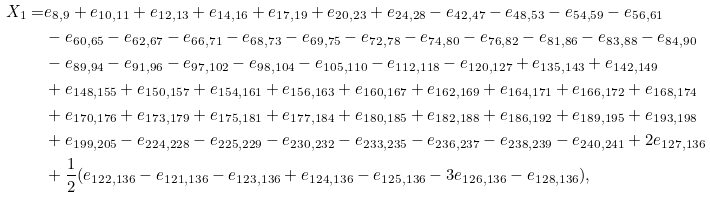Convert formula to latex. <formula><loc_0><loc_0><loc_500><loc_500>X _ { 1 } = & e _ { 8 , 9 } + e _ { 1 0 , 1 1 } + e _ { 1 2 , 1 3 } + e _ { 1 4 , 1 6 } + e _ { 1 7 , 1 9 } + e _ { 2 0 , 2 3 } + e _ { 2 4 , 2 8 } - e _ { 4 2 , 4 7 } - e _ { 4 8 , 5 3 } - e _ { 5 4 , 5 9 } - e _ { 5 6 , 6 1 } \\ & - e _ { 6 0 , 6 5 } - e _ { 6 2 , 6 7 } - e _ { 6 6 , 7 1 } - e _ { 6 8 , 7 3 } - e _ { 6 9 , 7 5 } - e _ { 7 2 , 7 8 } - e _ { 7 4 , 8 0 } - e _ { 7 6 , 8 2 } - e _ { 8 1 , 8 6 } - e _ { 8 3 , 8 8 } - e _ { 8 4 , 9 0 } \\ & - e _ { 8 9 , 9 4 } - e _ { 9 1 , 9 6 } - e _ { 9 7 , 1 0 2 } - e _ { 9 8 , 1 0 4 } - e _ { 1 0 5 , 1 1 0 } - e _ { 1 1 2 , 1 1 8 } - e _ { 1 2 0 , 1 2 7 } + e _ { 1 3 5 , 1 4 3 } + e _ { 1 4 2 , 1 4 9 } \\ & + e _ { 1 4 8 , 1 5 5 } + e _ { 1 5 0 , 1 5 7 } + e _ { 1 5 4 , 1 6 1 } + e _ { 1 5 6 , 1 6 3 } + e _ { 1 6 0 , 1 6 7 } + e _ { 1 6 2 , 1 6 9 } + e _ { 1 6 4 , 1 7 1 } + e _ { 1 6 6 , 1 7 2 } + e _ { 1 6 8 , 1 7 4 } \\ & + e _ { 1 7 0 , 1 7 6 } + e _ { 1 7 3 , 1 7 9 } + e _ { 1 7 5 , 1 8 1 } + e _ { 1 7 7 , 1 8 4 } + e _ { 1 8 0 , 1 8 5 } + e _ { 1 8 2 , 1 8 8 } + e _ { 1 8 6 , 1 9 2 } + e _ { 1 8 9 , 1 9 5 } + e _ { 1 9 3 , 1 9 8 } \\ & + e _ { 1 9 9 , 2 0 5 } - e _ { 2 2 4 , 2 2 8 } - e _ { 2 2 5 , 2 2 9 } - e _ { 2 3 0 , 2 3 2 } - e _ { 2 3 3 , 2 3 5 } - e _ { 2 3 6 , 2 3 7 } - e _ { 2 3 8 , 2 3 9 } - e _ { 2 4 0 , 2 4 1 } + 2 e _ { 1 2 7 , 1 3 6 } \\ & + \frac { 1 } { 2 } ( e _ { 1 2 2 , 1 3 6 } - e _ { 1 2 1 , 1 3 6 } - e _ { 1 2 3 , 1 3 6 } + e _ { 1 2 4 , 1 3 6 } - e _ { 1 2 5 , 1 3 6 } - 3 e _ { 1 2 6 , 1 3 6 } - e _ { 1 2 8 , 1 3 6 } ) ,</formula> 